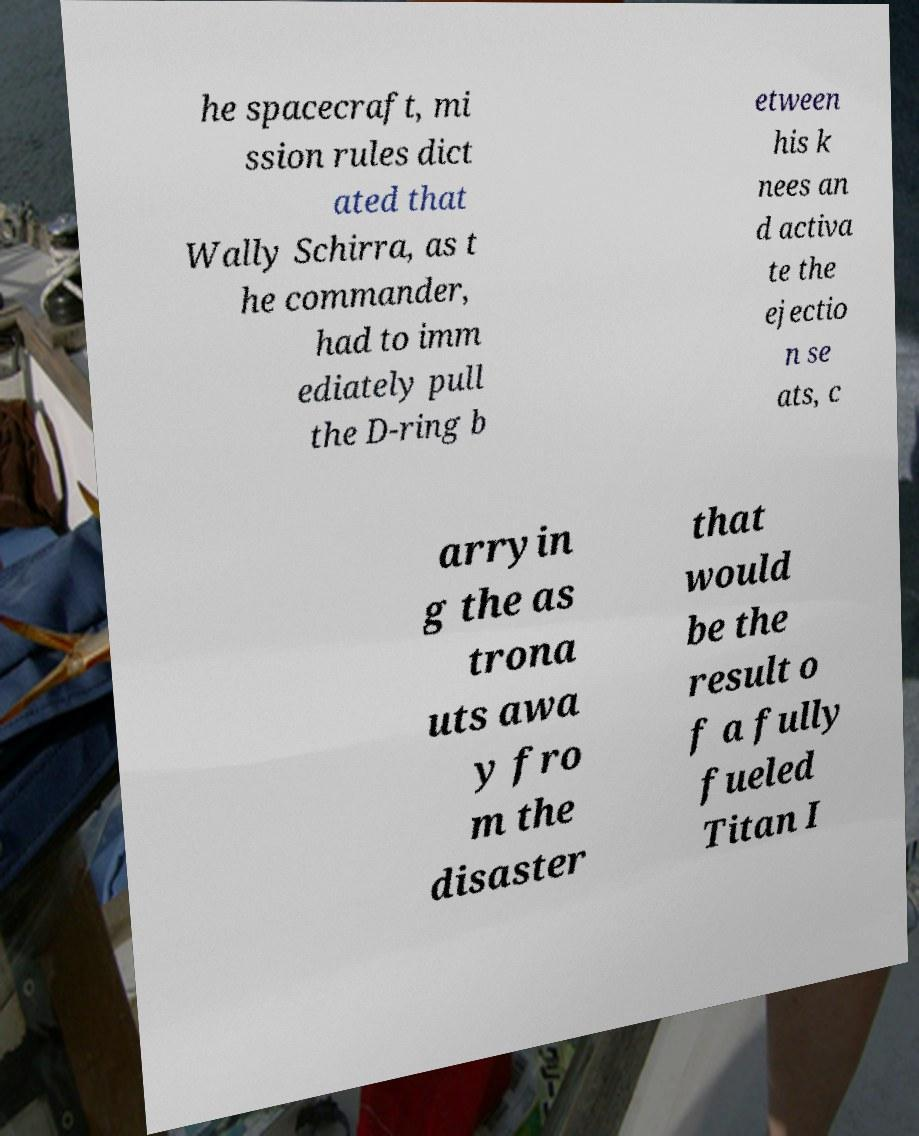Please read and relay the text visible in this image. What does it say? he spacecraft, mi ssion rules dict ated that Wally Schirra, as t he commander, had to imm ediately pull the D-ring b etween his k nees an d activa te the ejectio n se ats, c arryin g the as trona uts awa y fro m the disaster that would be the result o f a fully fueled Titan I 